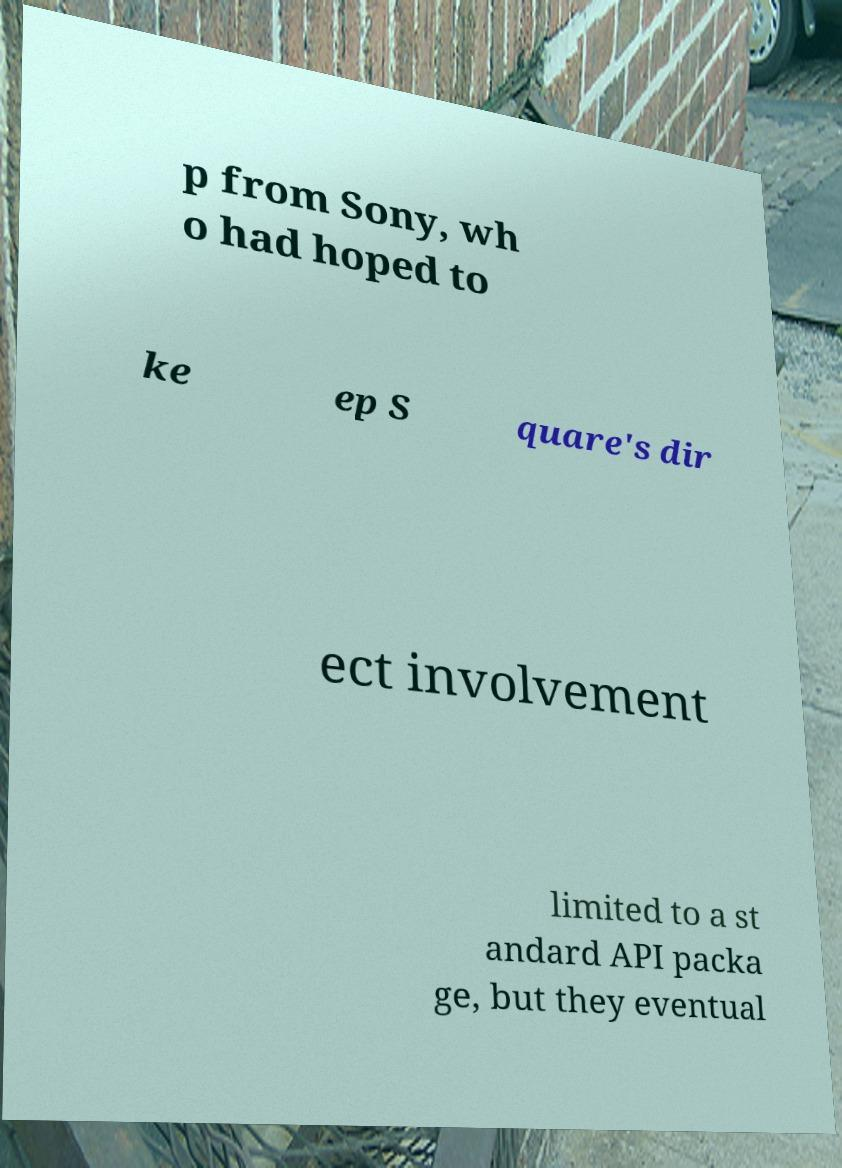What messages or text are displayed in this image? I need them in a readable, typed format. p from Sony, wh o had hoped to ke ep S quare's dir ect involvement limited to a st andard API packa ge, but they eventual 